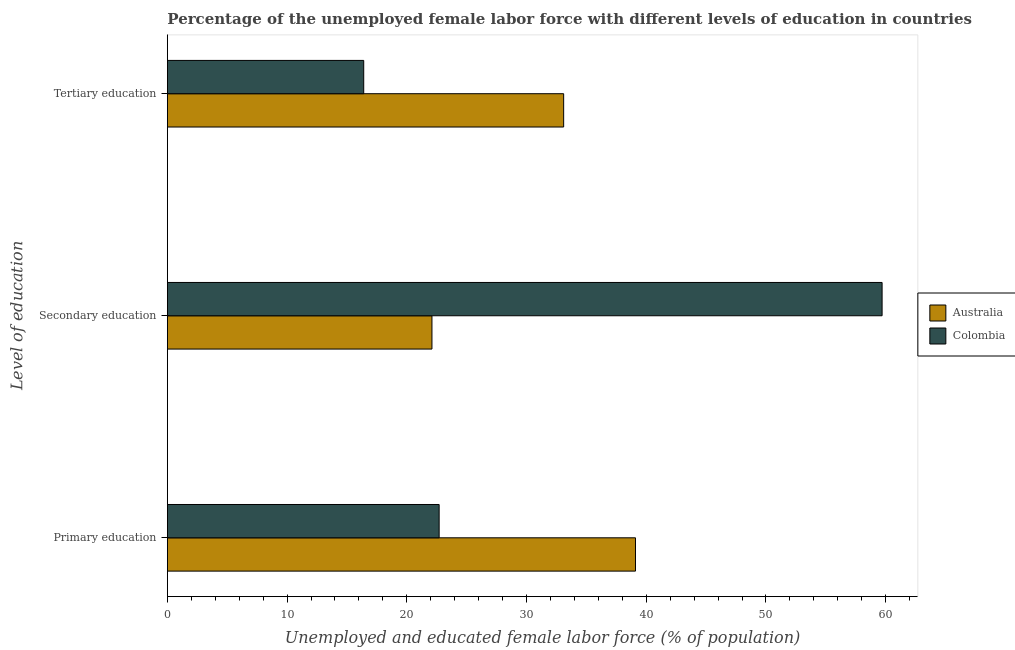How many groups of bars are there?
Provide a succinct answer. 3. How many bars are there on the 3rd tick from the bottom?
Keep it short and to the point. 2. What is the label of the 1st group of bars from the top?
Your answer should be compact. Tertiary education. What is the percentage of female labor force who received primary education in Australia?
Keep it short and to the point. 39.1. Across all countries, what is the maximum percentage of female labor force who received tertiary education?
Your answer should be very brief. 33.1. Across all countries, what is the minimum percentage of female labor force who received tertiary education?
Offer a terse response. 16.4. In which country was the percentage of female labor force who received tertiary education minimum?
Make the answer very short. Colombia. What is the total percentage of female labor force who received secondary education in the graph?
Offer a very short reply. 81.8. What is the difference between the percentage of female labor force who received primary education in Colombia and that in Australia?
Give a very brief answer. -16.4. What is the difference between the percentage of female labor force who received secondary education in Colombia and the percentage of female labor force who received primary education in Australia?
Offer a terse response. 20.6. What is the average percentage of female labor force who received tertiary education per country?
Offer a terse response. 24.75. What is the difference between the percentage of female labor force who received secondary education and percentage of female labor force who received primary education in Australia?
Ensure brevity in your answer.  -17. In how many countries, is the percentage of female labor force who received tertiary education greater than 40 %?
Offer a terse response. 0. What is the ratio of the percentage of female labor force who received secondary education in Colombia to that in Australia?
Ensure brevity in your answer.  2.7. Is the percentage of female labor force who received secondary education in Colombia less than that in Australia?
Ensure brevity in your answer.  No. Is the difference between the percentage of female labor force who received secondary education in Australia and Colombia greater than the difference between the percentage of female labor force who received primary education in Australia and Colombia?
Your answer should be compact. No. What is the difference between the highest and the second highest percentage of female labor force who received primary education?
Give a very brief answer. 16.4. What is the difference between the highest and the lowest percentage of female labor force who received primary education?
Provide a short and direct response. 16.4. Is the sum of the percentage of female labor force who received tertiary education in Colombia and Australia greater than the maximum percentage of female labor force who received secondary education across all countries?
Your response must be concise. No. What does the 1st bar from the top in Primary education represents?
Keep it short and to the point. Colombia. How many bars are there?
Provide a short and direct response. 6. Are all the bars in the graph horizontal?
Offer a very short reply. Yes. What is the difference between two consecutive major ticks on the X-axis?
Your answer should be very brief. 10. Are the values on the major ticks of X-axis written in scientific E-notation?
Provide a succinct answer. No. How many legend labels are there?
Keep it short and to the point. 2. How are the legend labels stacked?
Your answer should be compact. Vertical. What is the title of the graph?
Your answer should be compact. Percentage of the unemployed female labor force with different levels of education in countries. Does "Guyana" appear as one of the legend labels in the graph?
Your response must be concise. No. What is the label or title of the X-axis?
Your answer should be very brief. Unemployed and educated female labor force (% of population). What is the label or title of the Y-axis?
Keep it short and to the point. Level of education. What is the Unemployed and educated female labor force (% of population) in Australia in Primary education?
Provide a succinct answer. 39.1. What is the Unemployed and educated female labor force (% of population) of Colombia in Primary education?
Provide a succinct answer. 22.7. What is the Unemployed and educated female labor force (% of population) in Australia in Secondary education?
Offer a terse response. 22.1. What is the Unemployed and educated female labor force (% of population) of Colombia in Secondary education?
Offer a terse response. 59.7. What is the Unemployed and educated female labor force (% of population) of Australia in Tertiary education?
Your response must be concise. 33.1. What is the Unemployed and educated female labor force (% of population) in Colombia in Tertiary education?
Provide a short and direct response. 16.4. Across all Level of education, what is the maximum Unemployed and educated female labor force (% of population) of Australia?
Offer a terse response. 39.1. Across all Level of education, what is the maximum Unemployed and educated female labor force (% of population) of Colombia?
Ensure brevity in your answer.  59.7. Across all Level of education, what is the minimum Unemployed and educated female labor force (% of population) in Australia?
Offer a very short reply. 22.1. Across all Level of education, what is the minimum Unemployed and educated female labor force (% of population) in Colombia?
Provide a short and direct response. 16.4. What is the total Unemployed and educated female labor force (% of population) of Australia in the graph?
Your answer should be very brief. 94.3. What is the total Unemployed and educated female labor force (% of population) of Colombia in the graph?
Provide a short and direct response. 98.8. What is the difference between the Unemployed and educated female labor force (% of population) of Australia in Primary education and that in Secondary education?
Offer a very short reply. 17. What is the difference between the Unemployed and educated female labor force (% of population) in Colombia in Primary education and that in Secondary education?
Ensure brevity in your answer.  -37. What is the difference between the Unemployed and educated female labor force (% of population) in Colombia in Primary education and that in Tertiary education?
Offer a very short reply. 6.3. What is the difference between the Unemployed and educated female labor force (% of population) of Australia in Secondary education and that in Tertiary education?
Provide a short and direct response. -11. What is the difference between the Unemployed and educated female labor force (% of population) of Colombia in Secondary education and that in Tertiary education?
Offer a terse response. 43.3. What is the difference between the Unemployed and educated female labor force (% of population) in Australia in Primary education and the Unemployed and educated female labor force (% of population) in Colombia in Secondary education?
Provide a succinct answer. -20.6. What is the difference between the Unemployed and educated female labor force (% of population) in Australia in Primary education and the Unemployed and educated female labor force (% of population) in Colombia in Tertiary education?
Give a very brief answer. 22.7. What is the difference between the Unemployed and educated female labor force (% of population) in Australia in Secondary education and the Unemployed and educated female labor force (% of population) in Colombia in Tertiary education?
Make the answer very short. 5.7. What is the average Unemployed and educated female labor force (% of population) of Australia per Level of education?
Ensure brevity in your answer.  31.43. What is the average Unemployed and educated female labor force (% of population) of Colombia per Level of education?
Offer a very short reply. 32.93. What is the difference between the Unemployed and educated female labor force (% of population) in Australia and Unemployed and educated female labor force (% of population) in Colombia in Secondary education?
Your response must be concise. -37.6. What is the ratio of the Unemployed and educated female labor force (% of population) of Australia in Primary education to that in Secondary education?
Provide a short and direct response. 1.77. What is the ratio of the Unemployed and educated female labor force (% of population) of Colombia in Primary education to that in Secondary education?
Provide a short and direct response. 0.38. What is the ratio of the Unemployed and educated female labor force (% of population) of Australia in Primary education to that in Tertiary education?
Ensure brevity in your answer.  1.18. What is the ratio of the Unemployed and educated female labor force (% of population) in Colombia in Primary education to that in Tertiary education?
Offer a terse response. 1.38. What is the ratio of the Unemployed and educated female labor force (% of population) of Australia in Secondary education to that in Tertiary education?
Your answer should be very brief. 0.67. What is the ratio of the Unemployed and educated female labor force (% of population) in Colombia in Secondary education to that in Tertiary education?
Keep it short and to the point. 3.64. What is the difference between the highest and the second highest Unemployed and educated female labor force (% of population) in Australia?
Offer a terse response. 6. What is the difference between the highest and the lowest Unemployed and educated female labor force (% of population) of Colombia?
Make the answer very short. 43.3. 